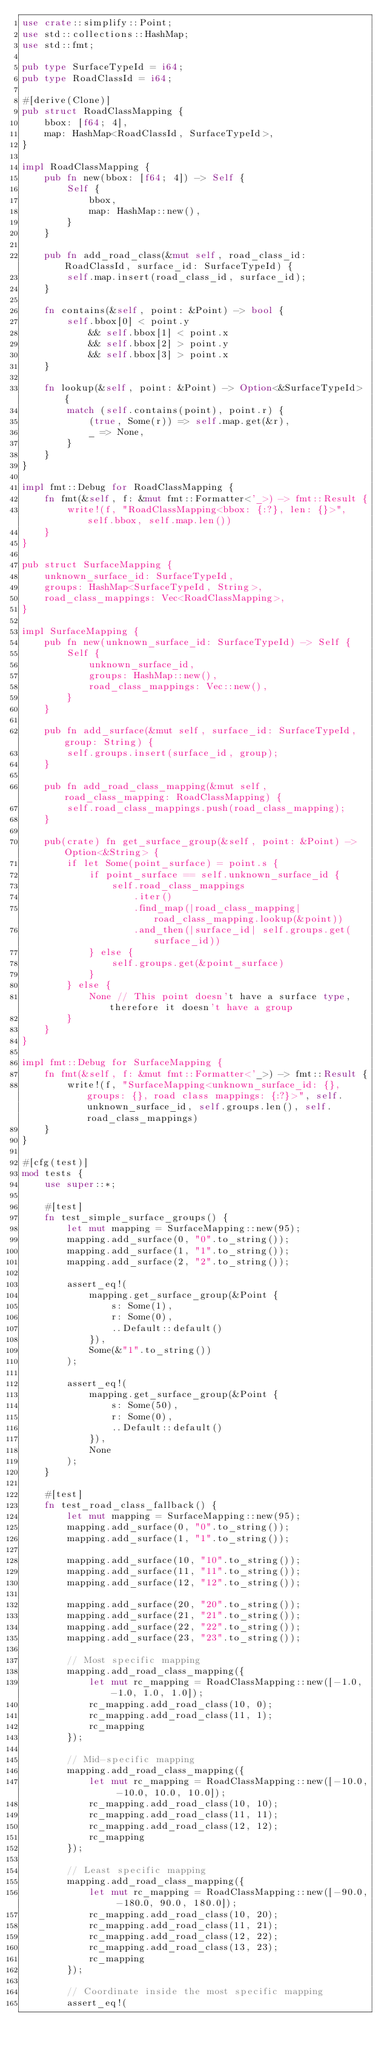Convert code to text. <code><loc_0><loc_0><loc_500><loc_500><_Rust_>use crate::simplify::Point;
use std::collections::HashMap;
use std::fmt;

pub type SurfaceTypeId = i64;
pub type RoadClassId = i64;

#[derive(Clone)]
pub struct RoadClassMapping {
    bbox: [f64; 4],
    map: HashMap<RoadClassId, SurfaceTypeId>,
}

impl RoadClassMapping {
    pub fn new(bbox: [f64; 4]) -> Self {
        Self {
            bbox,
            map: HashMap::new(),
        }
    }

    pub fn add_road_class(&mut self, road_class_id: RoadClassId, surface_id: SurfaceTypeId) {
        self.map.insert(road_class_id, surface_id);
    }

    fn contains(&self, point: &Point) -> bool {
        self.bbox[0] < point.y
            && self.bbox[1] < point.x
            && self.bbox[2] > point.y
            && self.bbox[3] > point.x
    }

    fn lookup(&self, point: &Point) -> Option<&SurfaceTypeId> {
        match (self.contains(point), point.r) {
            (true, Some(r)) => self.map.get(&r),
            _ => None,
        }
    }
}

impl fmt::Debug for RoadClassMapping {
    fn fmt(&self, f: &mut fmt::Formatter<'_>) -> fmt::Result {
        write!(f, "RoadClassMapping<bbox: {:?}, len: {}>", self.bbox, self.map.len())
    }
}

pub struct SurfaceMapping {
    unknown_surface_id: SurfaceTypeId,
    groups: HashMap<SurfaceTypeId, String>,
    road_class_mappings: Vec<RoadClassMapping>,
}

impl SurfaceMapping {
    pub fn new(unknown_surface_id: SurfaceTypeId) -> Self {
        Self {
            unknown_surface_id,
            groups: HashMap::new(),
            road_class_mappings: Vec::new(),
        }
    }

    pub fn add_surface(&mut self, surface_id: SurfaceTypeId, group: String) {
        self.groups.insert(surface_id, group);
    }

    pub fn add_road_class_mapping(&mut self, road_class_mapping: RoadClassMapping) {
        self.road_class_mappings.push(road_class_mapping);
    }

    pub(crate) fn get_surface_group(&self, point: &Point) -> Option<&String> {
        if let Some(point_surface) = point.s {
            if point_surface == self.unknown_surface_id {
                self.road_class_mappings
                    .iter()
                    .find_map(|road_class_mapping| road_class_mapping.lookup(&point))
                    .and_then(|surface_id| self.groups.get(surface_id))
            } else {
                self.groups.get(&point_surface)
            }
        } else {
            None // This point doesn't have a surface type, therefore it doesn't have a group
        }
    }
}

impl fmt::Debug for SurfaceMapping {
    fn fmt(&self, f: &mut fmt::Formatter<'_>) -> fmt::Result {
        write!(f, "SurfaceMapping<unknown_surface_id: {}, groups: {}, road class mappings: {:?}>", self.unknown_surface_id, self.groups.len(), self.road_class_mappings)
    }
}

#[cfg(test)]
mod tests {
    use super::*;

    #[test]
    fn test_simple_surface_groups() {
        let mut mapping = SurfaceMapping::new(95);
        mapping.add_surface(0, "0".to_string());
        mapping.add_surface(1, "1".to_string());
        mapping.add_surface(2, "2".to_string());

        assert_eq!(
            mapping.get_surface_group(&Point {
                s: Some(1),
                r: Some(0),
                ..Default::default()
            }),
            Some(&"1".to_string())
        );

        assert_eq!(
            mapping.get_surface_group(&Point {
                s: Some(50),
                r: Some(0),
                ..Default::default()
            }),
            None
        );
    }

    #[test]
    fn test_road_class_fallback() {
        let mut mapping = SurfaceMapping::new(95);
        mapping.add_surface(0, "0".to_string());
        mapping.add_surface(1, "1".to_string());

        mapping.add_surface(10, "10".to_string());
        mapping.add_surface(11, "11".to_string());
        mapping.add_surface(12, "12".to_string());

        mapping.add_surface(20, "20".to_string());
        mapping.add_surface(21, "21".to_string());
        mapping.add_surface(22, "22".to_string());
        mapping.add_surface(23, "23".to_string());

        // Most specific mapping
        mapping.add_road_class_mapping({
            let mut rc_mapping = RoadClassMapping::new([-1.0, -1.0, 1.0, 1.0]);
            rc_mapping.add_road_class(10, 0);
            rc_mapping.add_road_class(11, 1);
            rc_mapping
        });

        // Mid-specific mapping
        mapping.add_road_class_mapping({
            let mut rc_mapping = RoadClassMapping::new([-10.0, -10.0, 10.0, 10.0]);
            rc_mapping.add_road_class(10, 10);
            rc_mapping.add_road_class(11, 11);
            rc_mapping.add_road_class(12, 12);
            rc_mapping
        });

        // Least specific mapping
        mapping.add_road_class_mapping({
            let mut rc_mapping = RoadClassMapping::new([-90.0, -180.0, 90.0, 180.0]);
            rc_mapping.add_road_class(10, 20);
            rc_mapping.add_road_class(11, 21);
            rc_mapping.add_road_class(12, 22);
            rc_mapping.add_road_class(13, 23);
            rc_mapping
        });

        // Coordinate inside the most specific mapping
        assert_eq!(</code> 